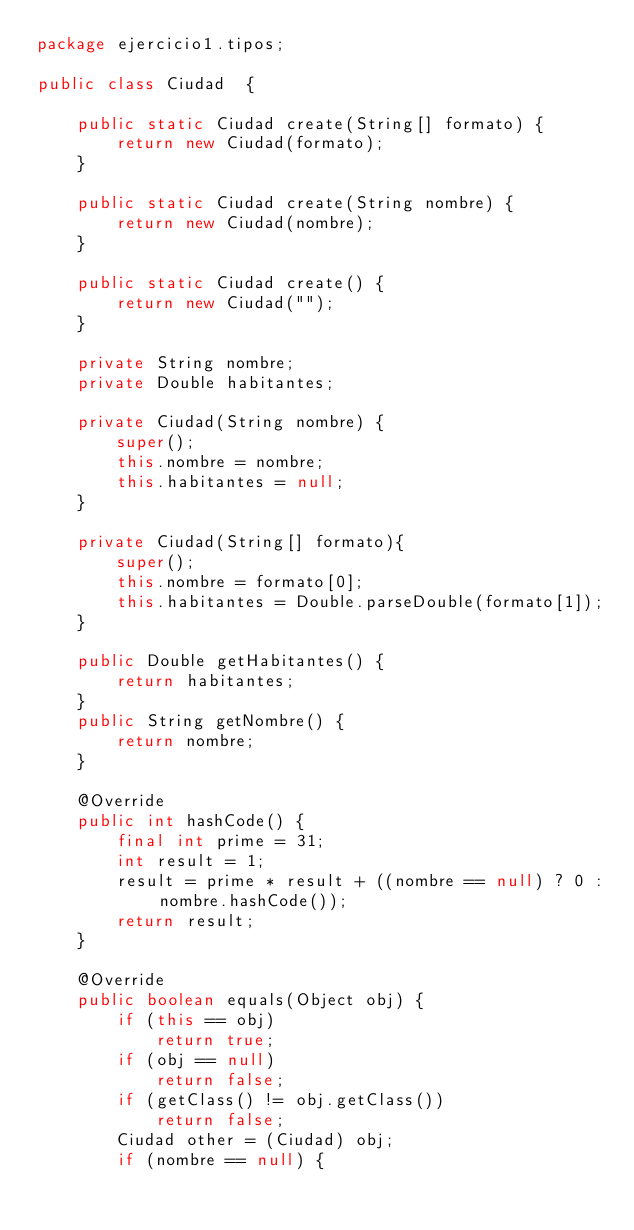<code> <loc_0><loc_0><loc_500><loc_500><_Java_>package ejercicio1.tipos;

public class Ciudad  {

	public static Ciudad create(String[] formato) {
		return new Ciudad(formato);
	}

	public static Ciudad create(String nombre) {
		return new Ciudad(nombre);
	}

	public static Ciudad create() {
		return new Ciudad("");
	}
	
	private String nombre;
	private Double habitantes;

	private Ciudad(String nombre) {
		super();
		this.nombre = nombre;
		this.habitantes = null;
	}

	private Ciudad(String[] formato){
		super();
		this.nombre = formato[0];
		this.habitantes = Double.parseDouble(formato[1]);
	}
	
	public Double getHabitantes() {
		return habitantes;
	}
	public String getNombre() {
		return nombre;
	}

	@Override
	public int hashCode() {
		final int prime = 31;
		int result = 1;
		result = prime * result + ((nombre == null) ? 0 : nombre.hashCode());
		return result;
	}

	@Override
	public boolean equals(Object obj) {
		if (this == obj)
			return true;
		if (obj == null)
			return false;
		if (getClass() != obj.getClass())
			return false;
		Ciudad other = (Ciudad) obj;
		if (nombre == null) {</code> 